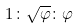<formula> <loc_0><loc_0><loc_500><loc_500>1 \colon \sqrt { \varphi } \colon \varphi</formula> 